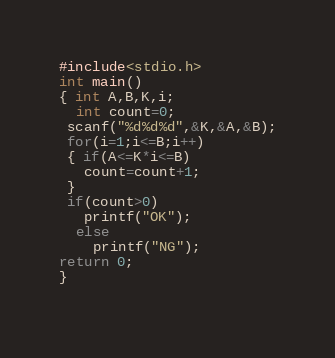Convert code to text. <code><loc_0><loc_0><loc_500><loc_500><_C_>#include<stdio.h>
int main()
{ int A,B,K,i;
  int count=0;
 scanf("%d%d%d",&K,&A,&B);
 for(i=1;i<=B;i++)
 { if(A<=K*i<=B)
   count=count+1;
 }
 if(count>0)
   printf("OK");
  else 
    printf("NG");
return 0;
}
 
</code> 